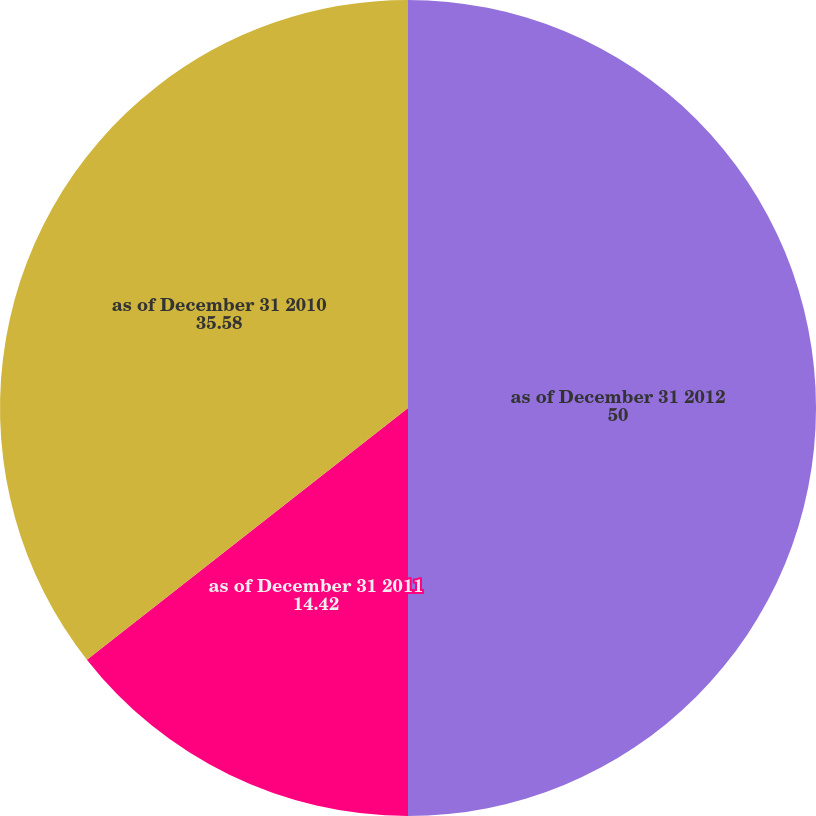<chart> <loc_0><loc_0><loc_500><loc_500><pie_chart><fcel>as of December 31 2012<fcel>as of December 31 2011<fcel>as of December 31 2010<nl><fcel>50.0%<fcel>14.42%<fcel>35.58%<nl></chart> 